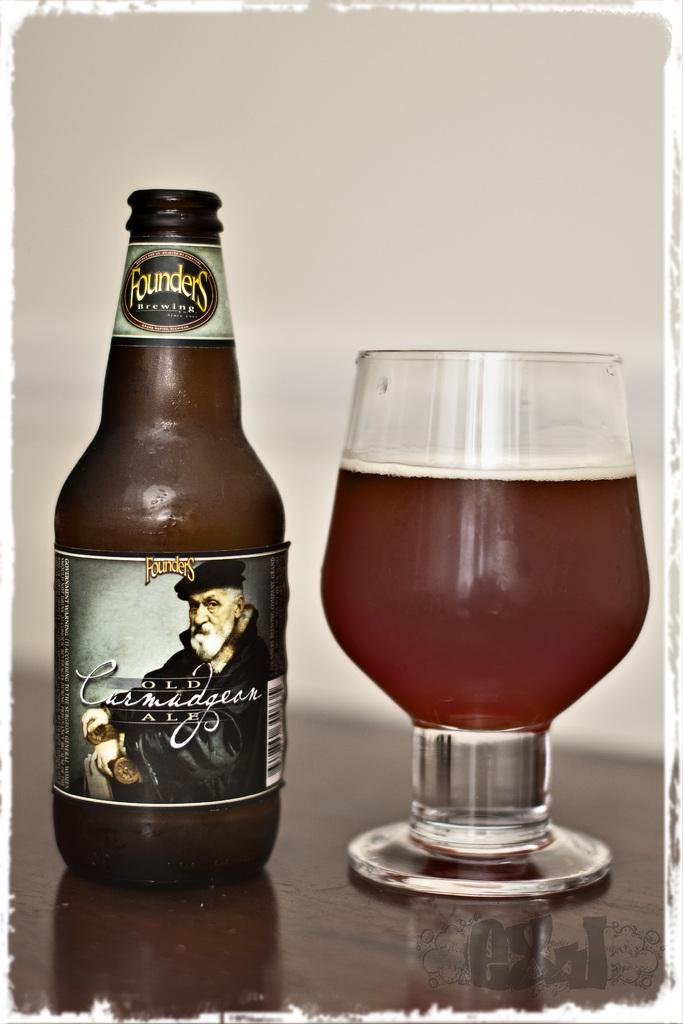What is in the glass that is visible in the image? There is a glass with liquid in the image. What can be seen on the bottle in the image? There is a bottle with text and an image in the image. Where are the glass and the bottle located in the image? Both the glass and the bottle are on a table. What is the position of the table in the image? The table is near a wall. What type of screw can be seen holding the bottle to the table in the image? There is no screw visible in the image, and the bottle is not attached to the table. 